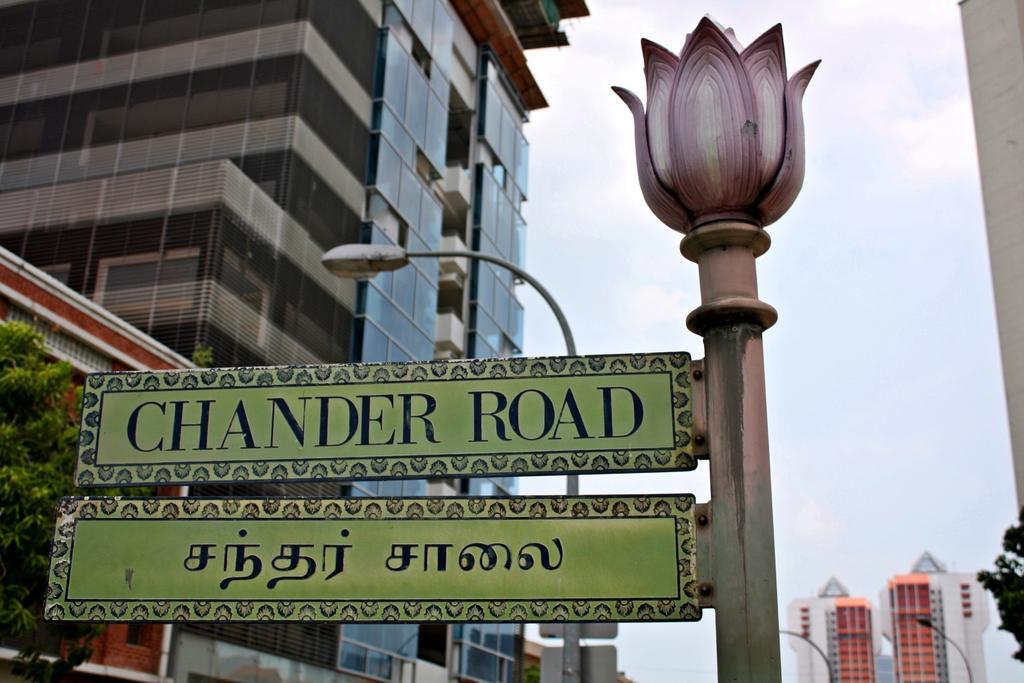In one or two sentences, can you explain what this image depicts? In this image I see a pole on which there are 2 boards and I see words written on it. In the background I see the buildings, trees and 3 light poles and I see the sky. 